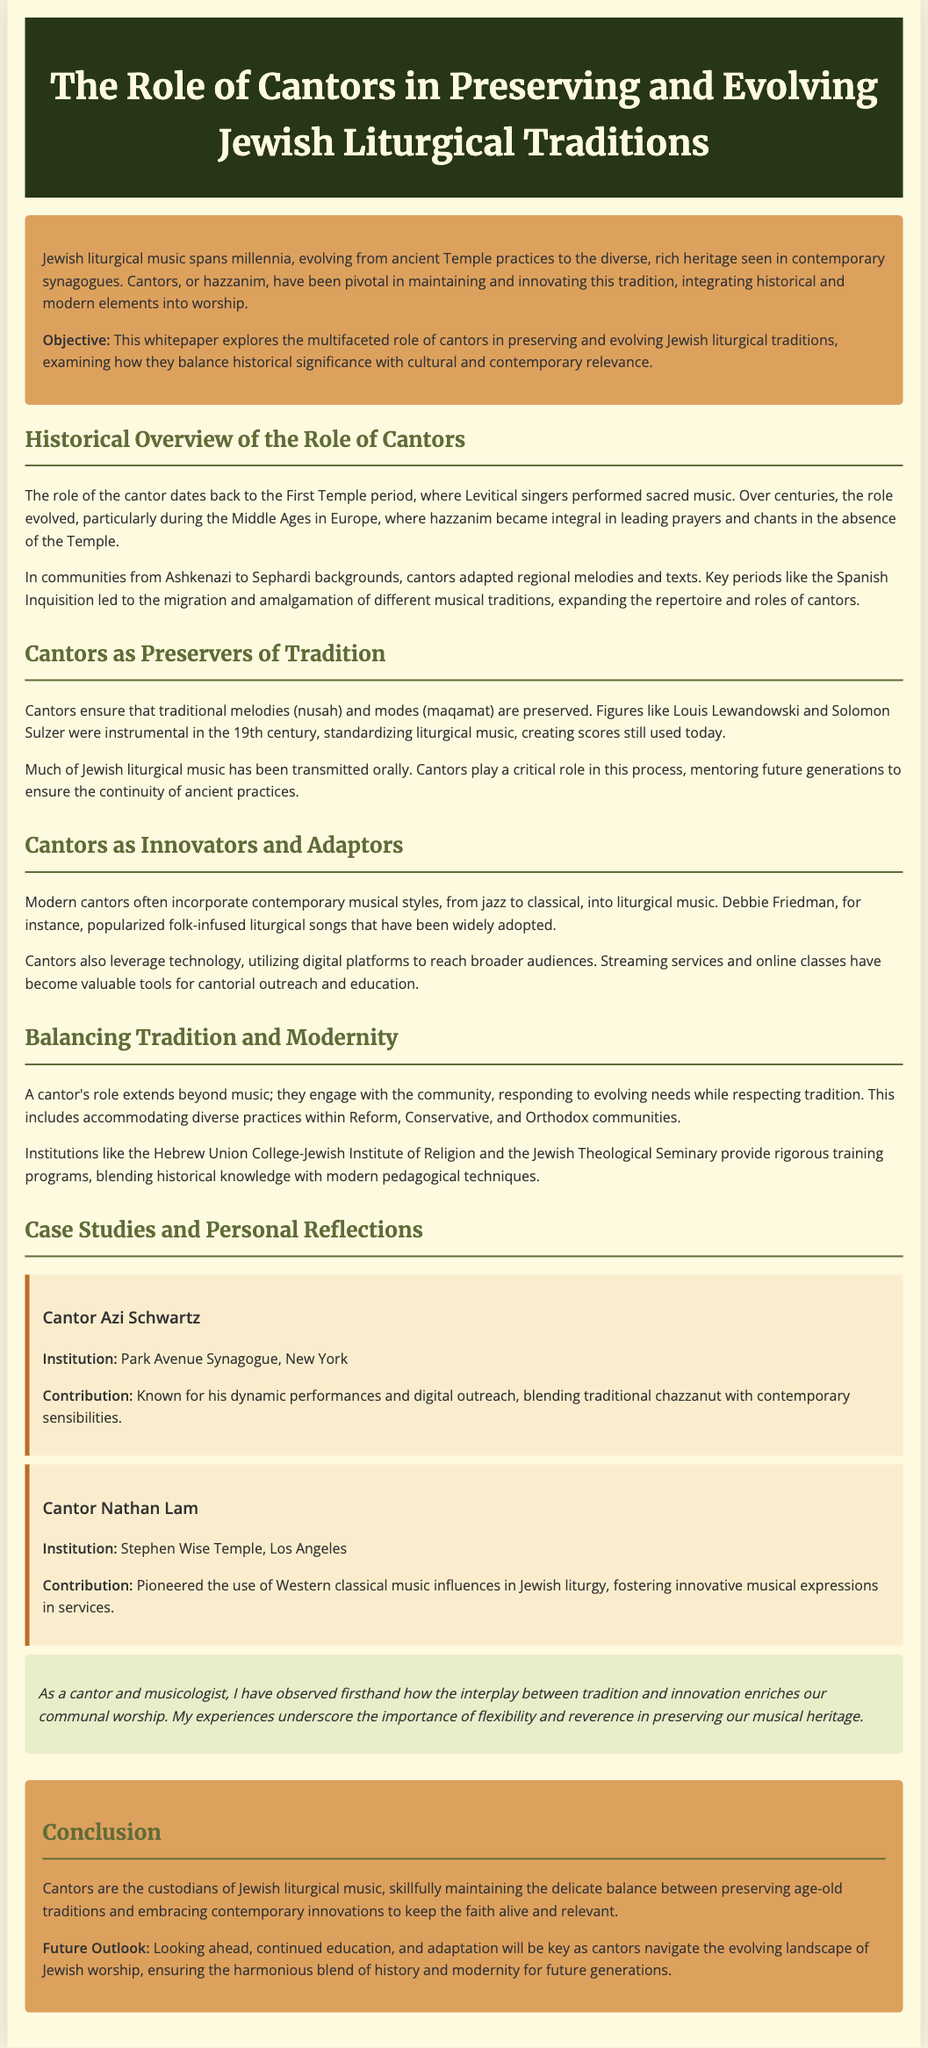what is the main objective of the whitepaper? The objective is to explore the multifaceted role of cantors in preserving and evolving Jewish liturgical traditions.
Answer: preserving and evolving Jewish liturgical traditions who were instrumental in standardizing liturgical music in the 19th century? Figures like Louis Lewandowski and Solomon Sulzer were key in this process.
Answer: Louis Lewandowski and Solomon Sulzer which contemporary musical style did Debbie Friedman popularize? Debbie Friedman is known for popularizing folk-infused liturgical songs.
Answer: folk-infused liturgical songs what institution is associated with Cantor Azi Schwartz? Cantor Azi Schwartz is associated with Park Avenue Synagogue.
Answer: Park Avenue Synagogue how do cantors engage with their communities? Cantors respond to evolving needs while respecting tradition, accommodating diverse practices.
Answer: responding to evolving needs while respecting tradition what is the role of cantors in Jewish liturgical music according to the conclusion? Cantors are custodians of Jewish liturgical music, balancing tradition and innovation.
Answer: custodians of Jewish liturgical music what is highlighted as key for the future outlook? Continued education and adaptation are noted as essential for future practices.
Answer: continued education and adaptation which two community types reflect the diverse practices mentioned in the document? The diverse practices include those within Reform and Conservative communities.
Answer: Reform and Conservative communities 